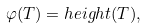<formula> <loc_0><loc_0><loc_500><loc_500>\varphi ( T ) = h e i g h t ( T ) ,</formula> 